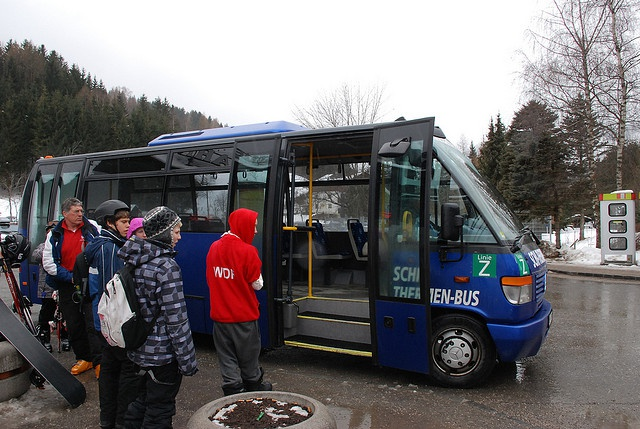Describe the objects in this image and their specific colors. I can see bus in white, black, gray, navy, and darkgray tones, people in white, black, gray, darkgray, and navy tones, people in white, brown, black, and maroon tones, people in white, black, brown, maroon, and navy tones, and people in white, black, navy, gray, and darkblue tones in this image. 